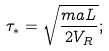Convert formula to latex. <formula><loc_0><loc_0><loc_500><loc_500>\tau _ { * } = \sqrt { \frac { m a L } { 2 V _ { R } } } ;</formula> 